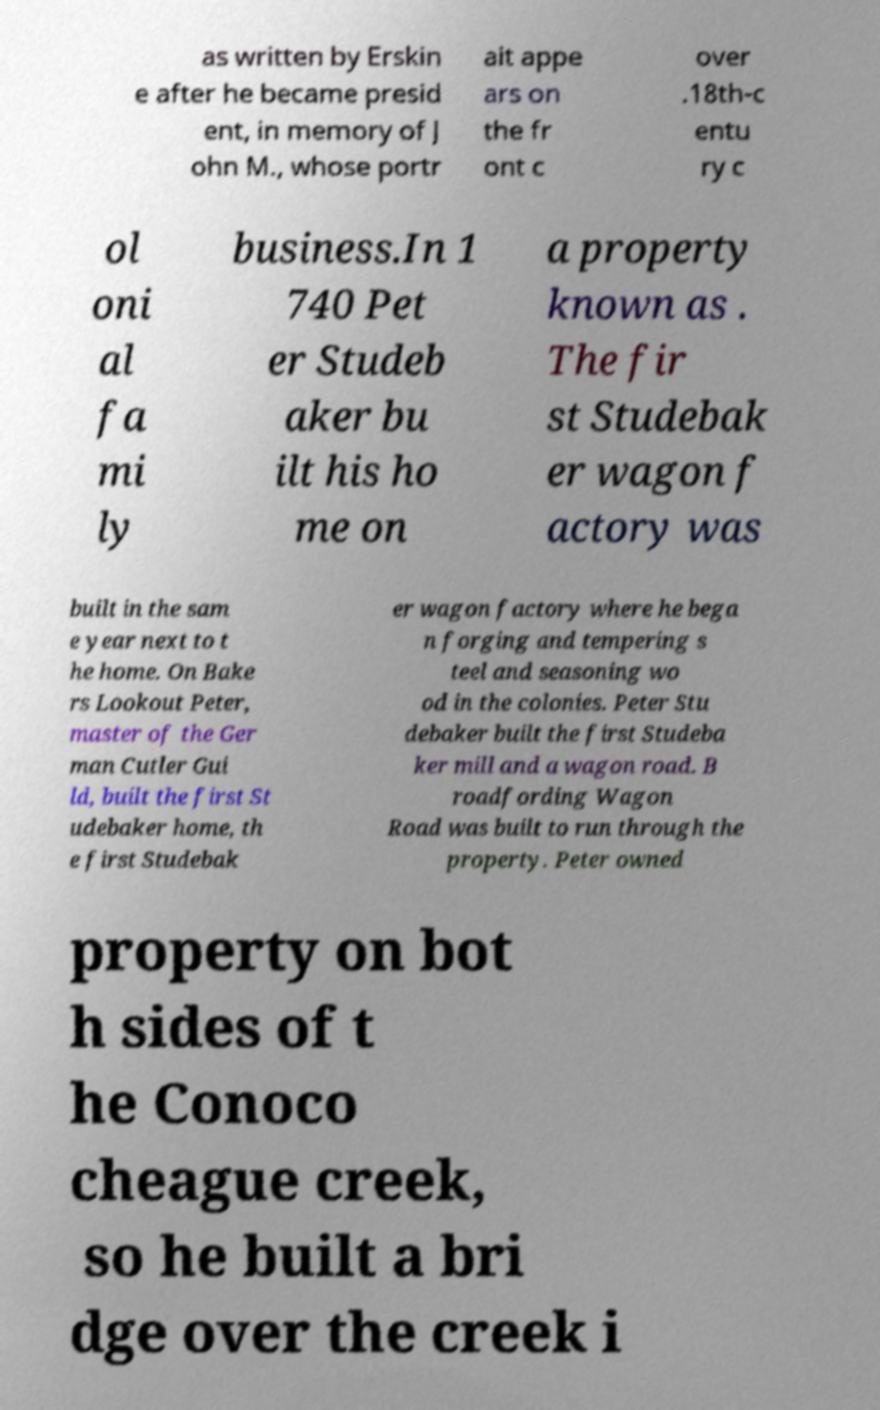For documentation purposes, I need the text within this image transcribed. Could you provide that? as written by Erskin e after he became presid ent, in memory of J ohn M., whose portr ait appe ars on the fr ont c over .18th-c entu ry c ol oni al fa mi ly business.In 1 740 Pet er Studeb aker bu ilt his ho me on a property known as . The fir st Studebak er wagon f actory was built in the sam e year next to t he home. On Bake rs Lookout Peter, master of the Ger man Cutler Gui ld, built the first St udebaker home, th e first Studebak er wagon factory where he bega n forging and tempering s teel and seasoning wo od in the colonies. Peter Stu debaker built the first Studeba ker mill and a wagon road. B roadfording Wagon Road was built to run through the property. Peter owned property on bot h sides of t he Conoco cheague creek, so he built a bri dge over the creek i 